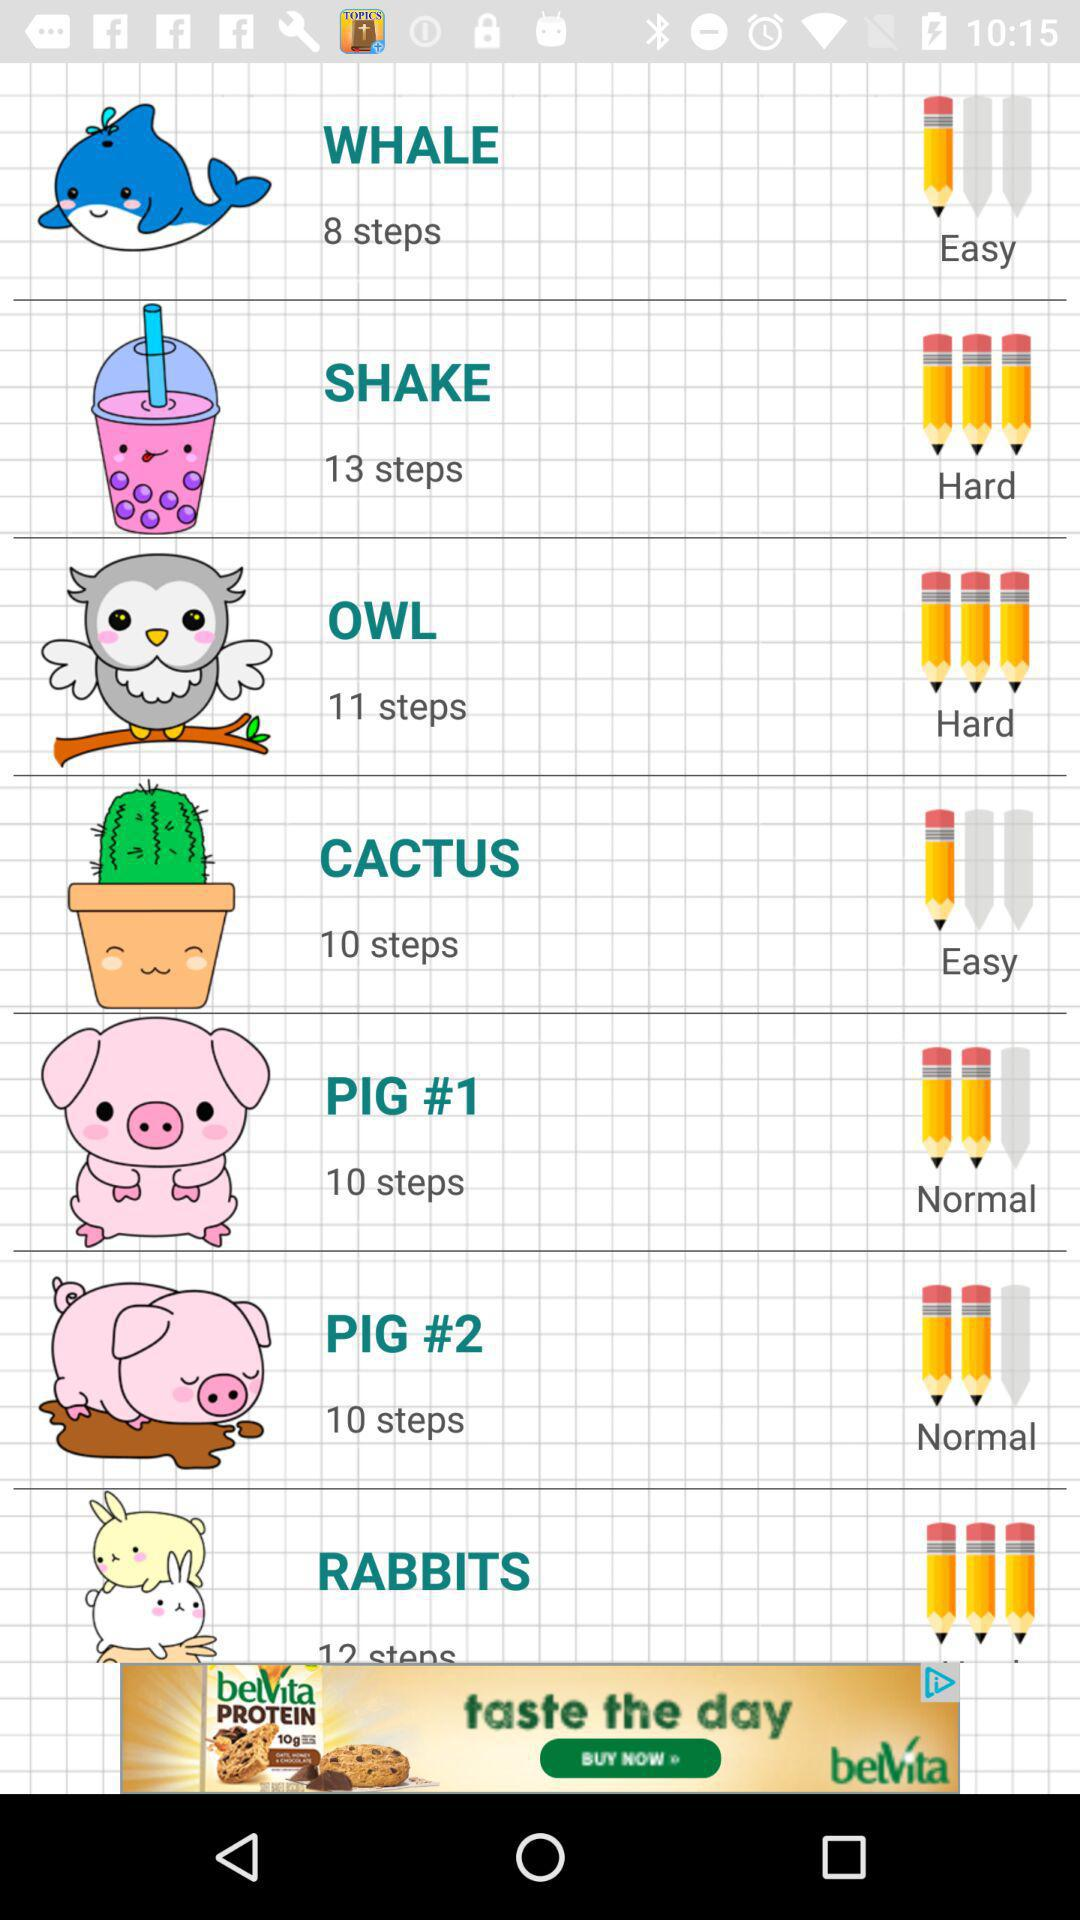Is OWL easy or hard? The OWL is hard. 